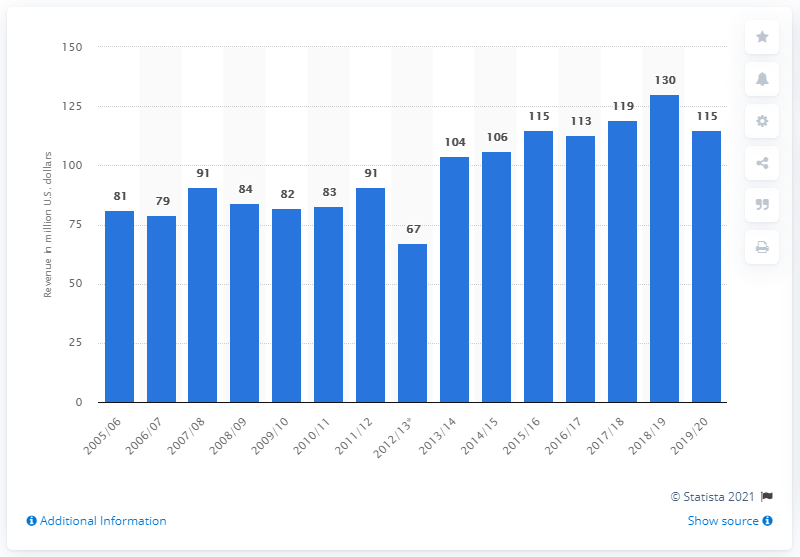Identify some key points in this picture. The Colorado Avalanche's revenue in the 2019/2020 season was approximately 115 million dollars. 